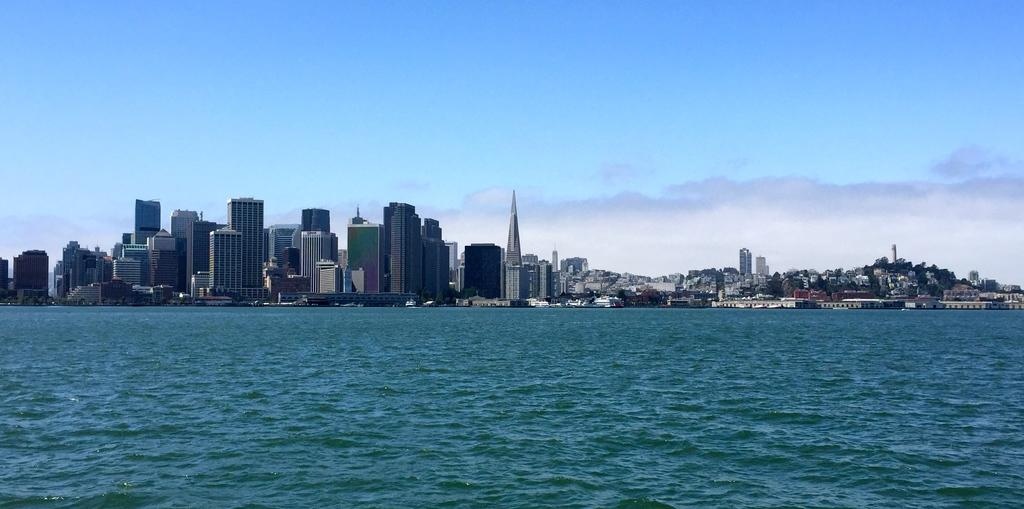What is the primary element visible in the picture? There is water in the picture. What can be seen in the distance in the picture? There are buildings in the background of the picture. Who is using a knife to control the water in the image? There is no person or knife present in the image, and therefore no such action can be observed. 